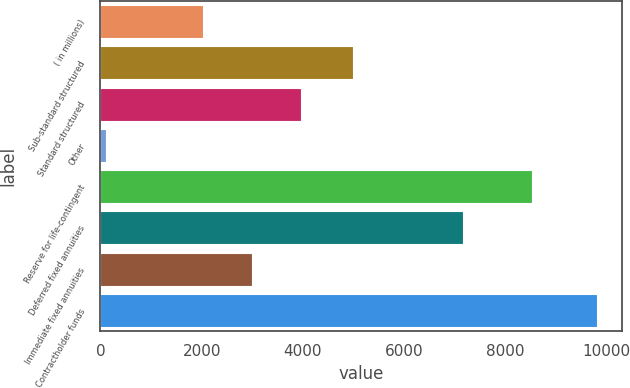<chart> <loc_0><loc_0><loc_500><loc_500><bar_chart><fcel>( in millions)<fcel>Sub-standard structured<fcel>Standard structured<fcel>Other<fcel>Reserve for life-contingent<fcel>Deferred fixed annuities<fcel>Immediate fixed annuities<fcel>Contractholder funds<nl><fcel>2018<fcel>4990<fcel>3959.6<fcel>109<fcel>8524<fcel>7156<fcel>2988.8<fcel>9817<nl></chart> 